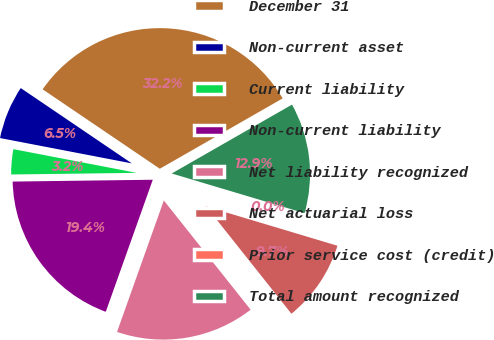Convert chart. <chart><loc_0><loc_0><loc_500><loc_500><pie_chart><fcel>December 31<fcel>Non-current asset<fcel>Current liability<fcel>Non-current liability<fcel>Net liability recognized<fcel>Net actuarial loss<fcel>Prior service cost (credit)<fcel>Total amount recognized<nl><fcel>32.24%<fcel>6.46%<fcel>3.23%<fcel>19.35%<fcel>16.13%<fcel>9.68%<fcel>0.01%<fcel>12.9%<nl></chart> 